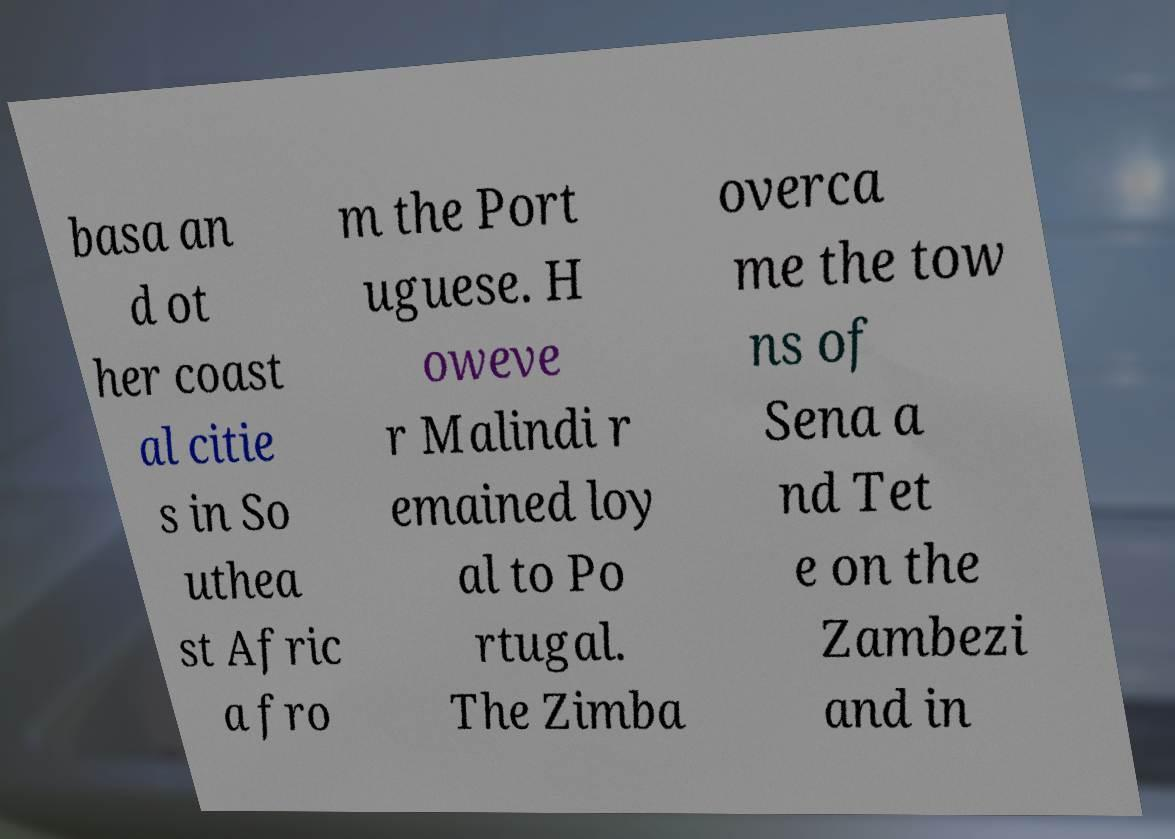Can you accurately transcribe the text from the provided image for me? basa an d ot her coast al citie s in So uthea st Afric a fro m the Port uguese. H oweve r Malindi r emained loy al to Po rtugal. The Zimba overca me the tow ns of Sena a nd Tet e on the Zambezi and in 